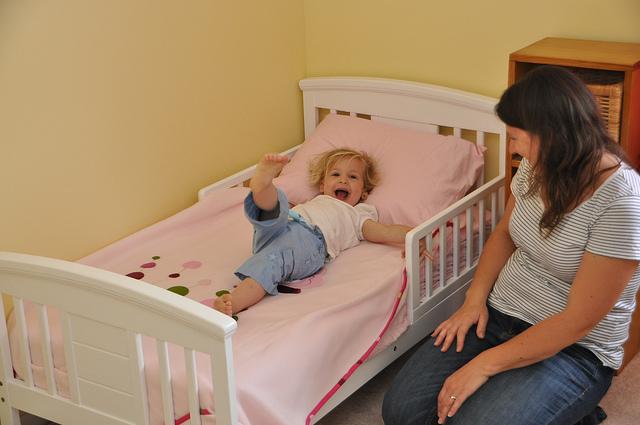Which child is not smiling?
Quick response, please. None. Is this baby happy?
Give a very brief answer. Yes. How are the people likely related?
Write a very short answer. Mother and child. Why does she have her leg up?
Answer briefly. Kicking. 